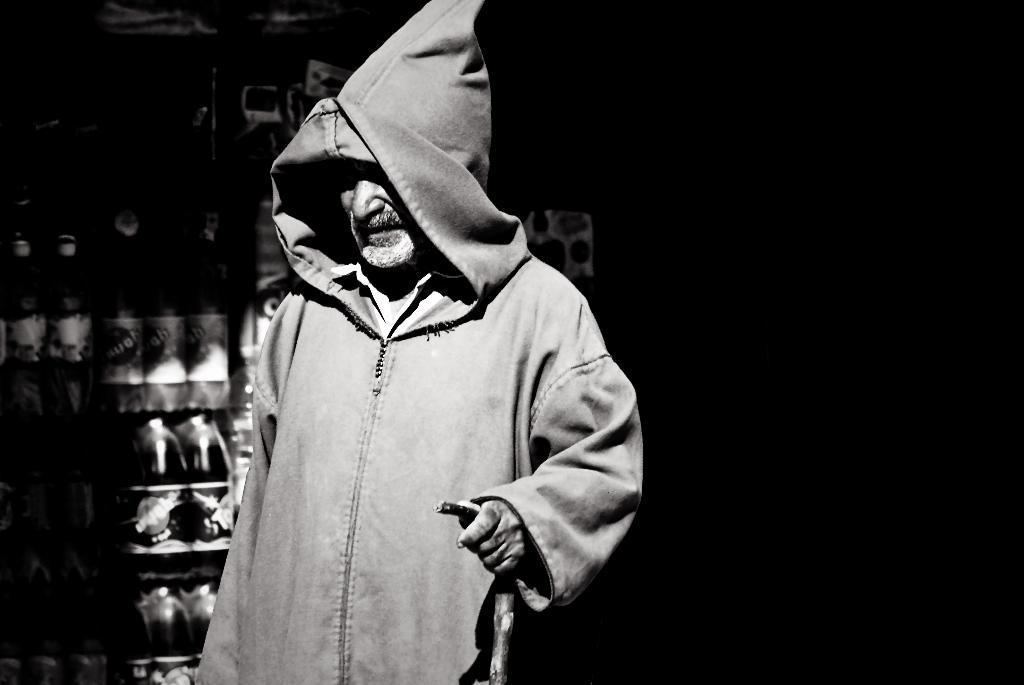How would you summarize this image in a sentence or two? In this image there is a person wearing a hooded jacket is holding a stick in his hand, behind the person there are packed bottled drinks. 